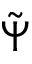<formula> <loc_0><loc_0><loc_500><loc_500>\tilde { \Psi }</formula> 